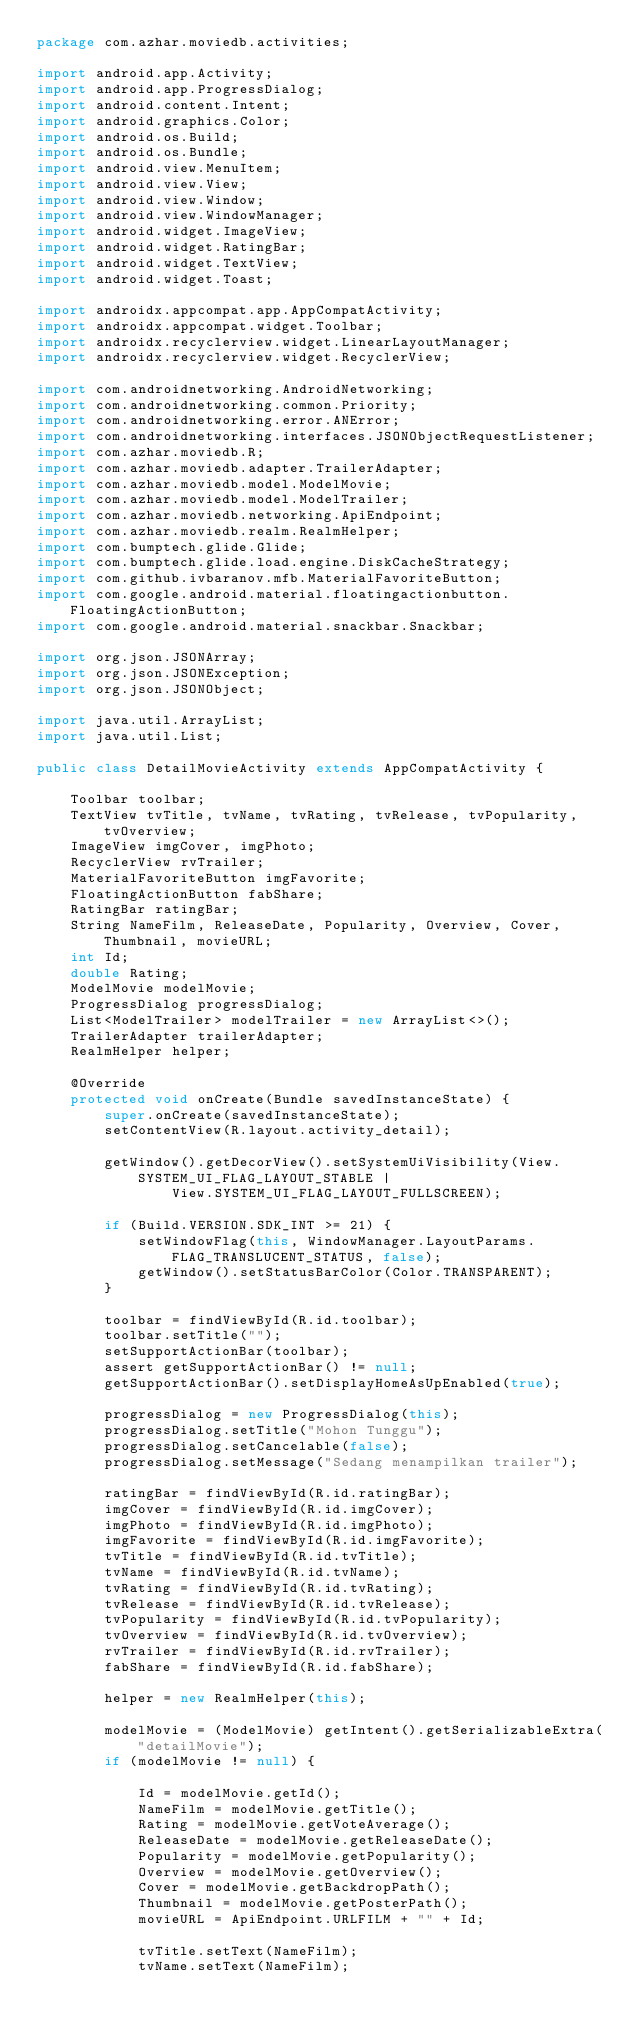<code> <loc_0><loc_0><loc_500><loc_500><_Java_>package com.azhar.moviedb.activities;

import android.app.Activity;
import android.app.ProgressDialog;
import android.content.Intent;
import android.graphics.Color;
import android.os.Build;
import android.os.Bundle;
import android.view.MenuItem;
import android.view.View;
import android.view.Window;
import android.view.WindowManager;
import android.widget.ImageView;
import android.widget.RatingBar;
import android.widget.TextView;
import android.widget.Toast;

import androidx.appcompat.app.AppCompatActivity;
import androidx.appcompat.widget.Toolbar;
import androidx.recyclerview.widget.LinearLayoutManager;
import androidx.recyclerview.widget.RecyclerView;

import com.androidnetworking.AndroidNetworking;
import com.androidnetworking.common.Priority;
import com.androidnetworking.error.ANError;
import com.androidnetworking.interfaces.JSONObjectRequestListener;
import com.azhar.moviedb.R;
import com.azhar.moviedb.adapter.TrailerAdapter;
import com.azhar.moviedb.model.ModelMovie;
import com.azhar.moviedb.model.ModelTrailer;
import com.azhar.moviedb.networking.ApiEndpoint;
import com.azhar.moviedb.realm.RealmHelper;
import com.bumptech.glide.Glide;
import com.bumptech.glide.load.engine.DiskCacheStrategy;
import com.github.ivbaranov.mfb.MaterialFavoriteButton;
import com.google.android.material.floatingactionbutton.FloatingActionButton;
import com.google.android.material.snackbar.Snackbar;

import org.json.JSONArray;
import org.json.JSONException;
import org.json.JSONObject;

import java.util.ArrayList;
import java.util.List;

public class DetailMovieActivity extends AppCompatActivity {

    Toolbar toolbar;
    TextView tvTitle, tvName, tvRating, tvRelease, tvPopularity, tvOverview;
    ImageView imgCover, imgPhoto;
    RecyclerView rvTrailer;
    MaterialFavoriteButton imgFavorite;
    FloatingActionButton fabShare;
    RatingBar ratingBar;
    String NameFilm, ReleaseDate, Popularity, Overview, Cover, Thumbnail, movieURL;
    int Id;
    double Rating;
    ModelMovie modelMovie;
    ProgressDialog progressDialog;
    List<ModelTrailer> modelTrailer = new ArrayList<>();
    TrailerAdapter trailerAdapter;
    RealmHelper helper;

    @Override
    protected void onCreate(Bundle savedInstanceState) {
        super.onCreate(savedInstanceState);
        setContentView(R.layout.activity_detail);

        getWindow().getDecorView().setSystemUiVisibility(View.SYSTEM_UI_FLAG_LAYOUT_STABLE |
                View.SYSTEM_UI_FLAG_LAYOUT_FULLSCREEN);

        if (Build.VERSION.SDK_INT >= 21) {
            setWindowFlag(this, WindowManager.LayoutParams.FLAG_TRANSLUCENT_STATUS, false);
            getWindow().setStatusBarColor(Color.TRANSPARENT);
        }

        toolbar = findViewById(R.id.toolbar);
        toolbar.setTitle("");
        setSupportActionBar(toolbar);
        assert getSupportActionBar() != null;
        getSupportActionBar().setDisplayHomeAsUpEnabled(true);

        progressDialog = new ProgressDialog(this);
        progressDialog.setTitle("Mohon Tunggu");
        progressDialog.setCancelable(false);
        progressDialog.setMessage("Sedang menampilkan trailer");

        ratingBar = findViewById(R.id.ratingBar);
        imgCover = findViewById(R.id.imgCover);
        imgPhoto = findViewById(R.id.imgPhoto);
        imgFavorite = findViewById(R.id.imgFavorite);
        tvTitle = findViewById(R.id.tvTitle);
        tvName = findViewById(R.id.tvName);
        tvRating = findViewById(R.id.tvRating);
        tvRelease = findViewById(R.id.tvRelease);
        tvPopularity = findViewById(R.id.tvPopularity);
        tvOverview = findViewById(R.id.tvOverview);
        rvTrailer = findViewById(R.id.rvTrailer);
        fabShare = findViewById(R.id.fabShare);

        helper = new RealmHelper(this);

        modelMovie = (ModelMovie) getIntent().getSerializableExtra("detailMovie");
        if (modelMovie != null) {

            Id = modelMovie.getId();
            NameFilm = modelMovie.getTitle();
            Rating = modelMovie.getVoteAverage();
            ReleaseDate = modelMovie.getReleaseDate();
            Popularity = modelMovie.getPopularity();
            Overview = modelMovie.getOverview();
            Cover = modelMovie.getBackdropPath();
            Thumbnail = modelMovie.getPosterPath();
            movieURL = ApiEndpoint.URLFILM + "" + Id;

            tvTitle.setText(NameFilm);
            tvName.setText(NameFilm);</code> 